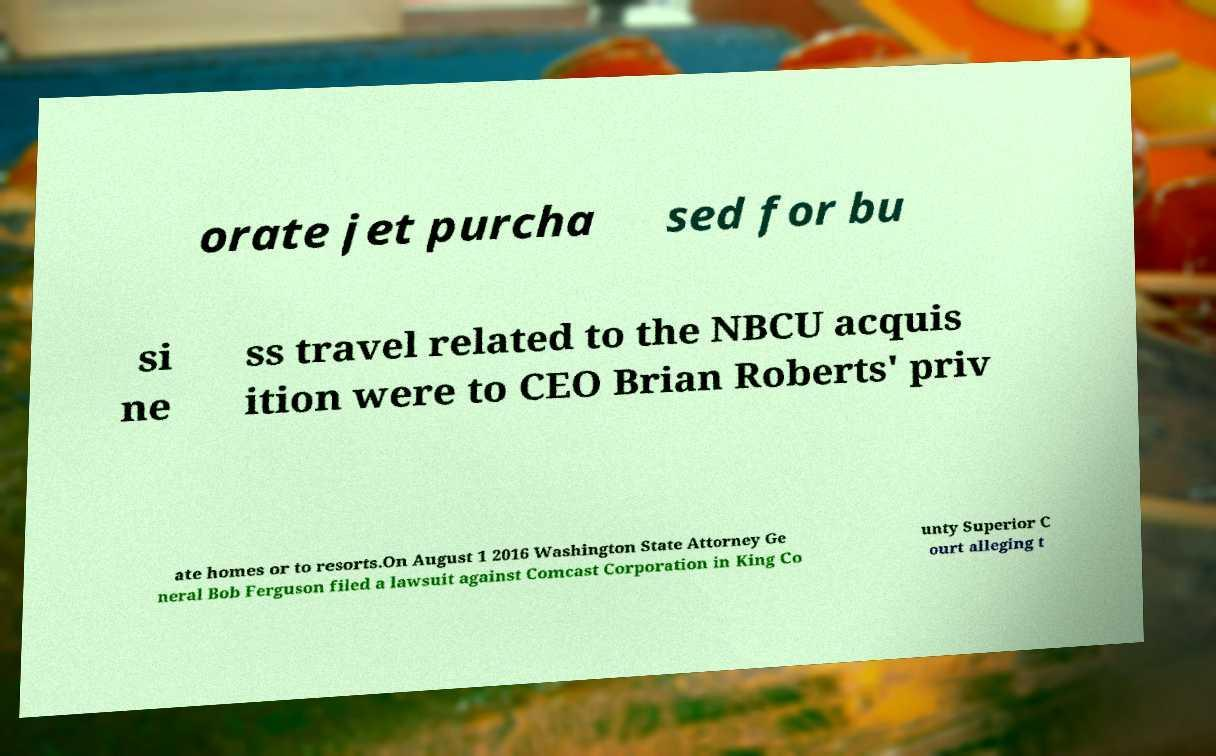Can you accurately transcribe the text from the provided image for me? orate jet purcha sed for bu si ne ss travel related to the NBCU acquis ition were to CEO Brian Roberts' priv ate homes or to resorts.On August 1 2016 Washington State Attorney Ge neral Bob Ferguson filed a lawsuit against Comcast Corporation in King Co unty Superior C ourt alleging t 